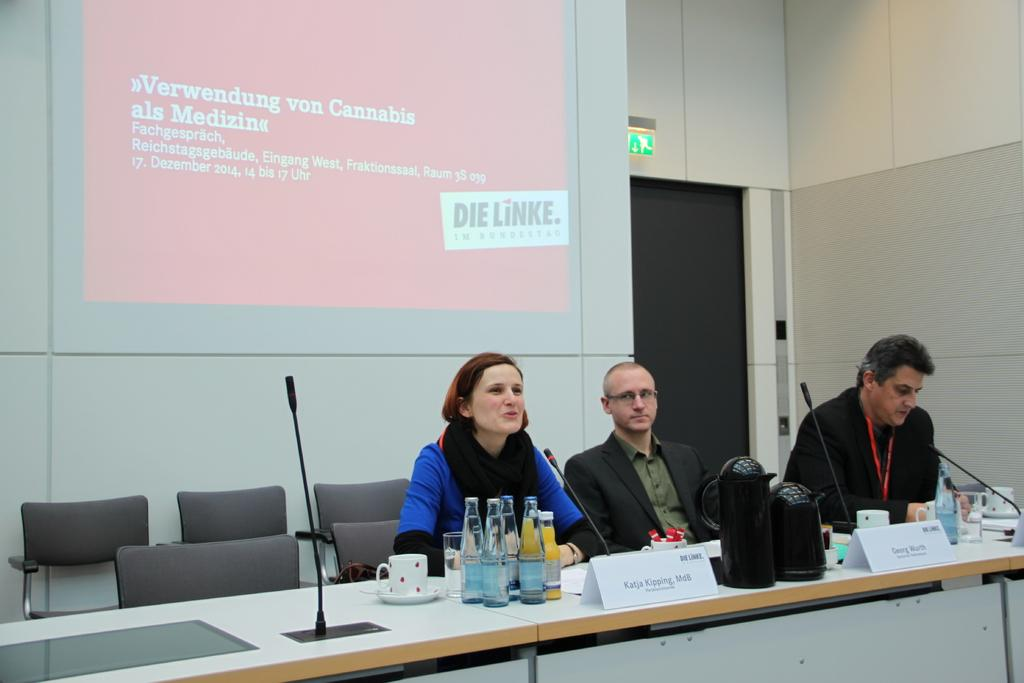How many people are seated in the image? There are three people seated in the image. What are the people seated on? The people are seated on chairs. What items can be seen on the table in the image? There are water bottles, cups, and microphones on the table. What is visible on the wall or hanging from the ceiling in the image? There is a projector screen visible in the image. Are there any spiders crawling on the projector screen in the image? There is no mention of spiders in the provided facts, and therefore we cannot determine if there are any spiders present in the image. 